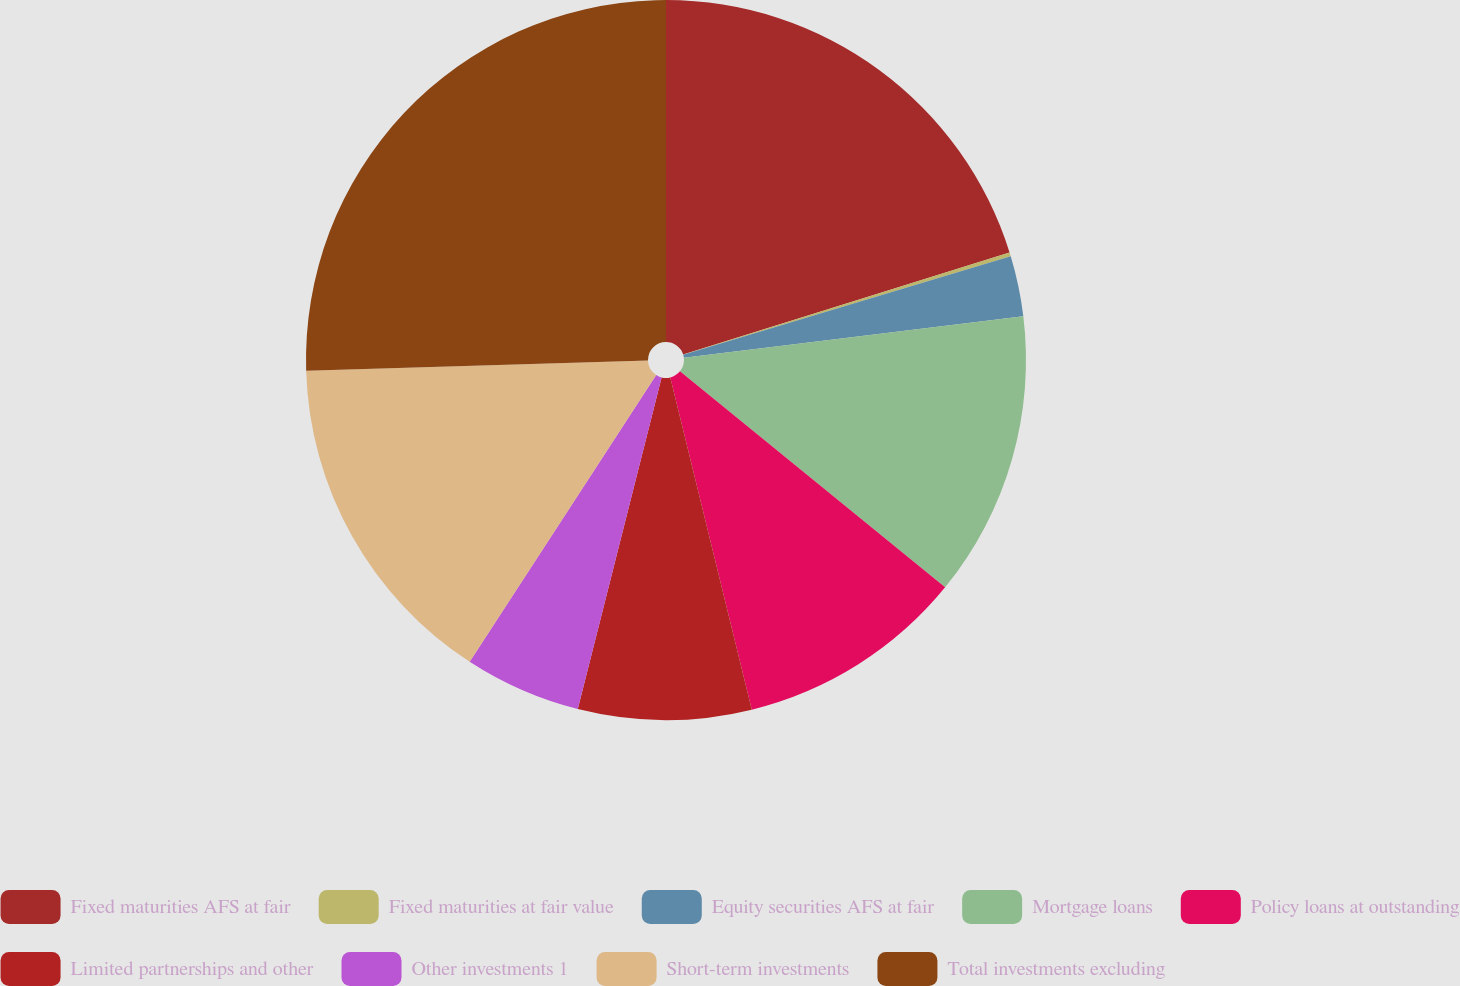Convert chart. <chart><loc_0><loc_0><loc_500><loc_500><pie_chart><fcel>Fixed maturities AFS at fair<fcel>Fixed maturities at fair value<fcel>Equity securities AFS at fair<fcel>Mortgage loans<fcel>Policy loans at outstanding<fcel>Limited partnerships and other<fcel>Other investments 1<fcel>Short-term investments<fcel>Total investments excluding<nl><fcel>20.17%<fcel>0.18%<fcel>2.71%<fcel>12.82%<fcel>10.29%<fcel>7.77%<fcel>5.24%<fcel>15.35%<fcel>25.47%<nl></chart> 